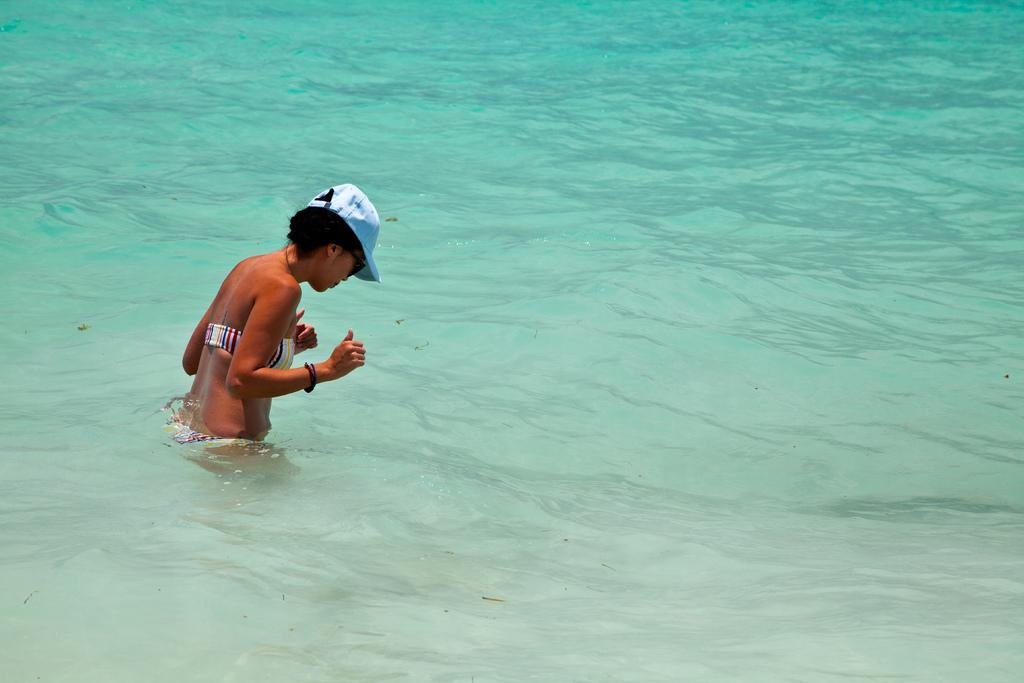How many people are in the image? There is one person in the image. What is visible in the image besides the person? Water is visible in the image. What type of note is the person holding in the image? There is no note visible in the image; only the person and water are present. What is the person's stomach doing in the image? There is no indication of the person's stomach in the image, as the focus is on the person and the water. 